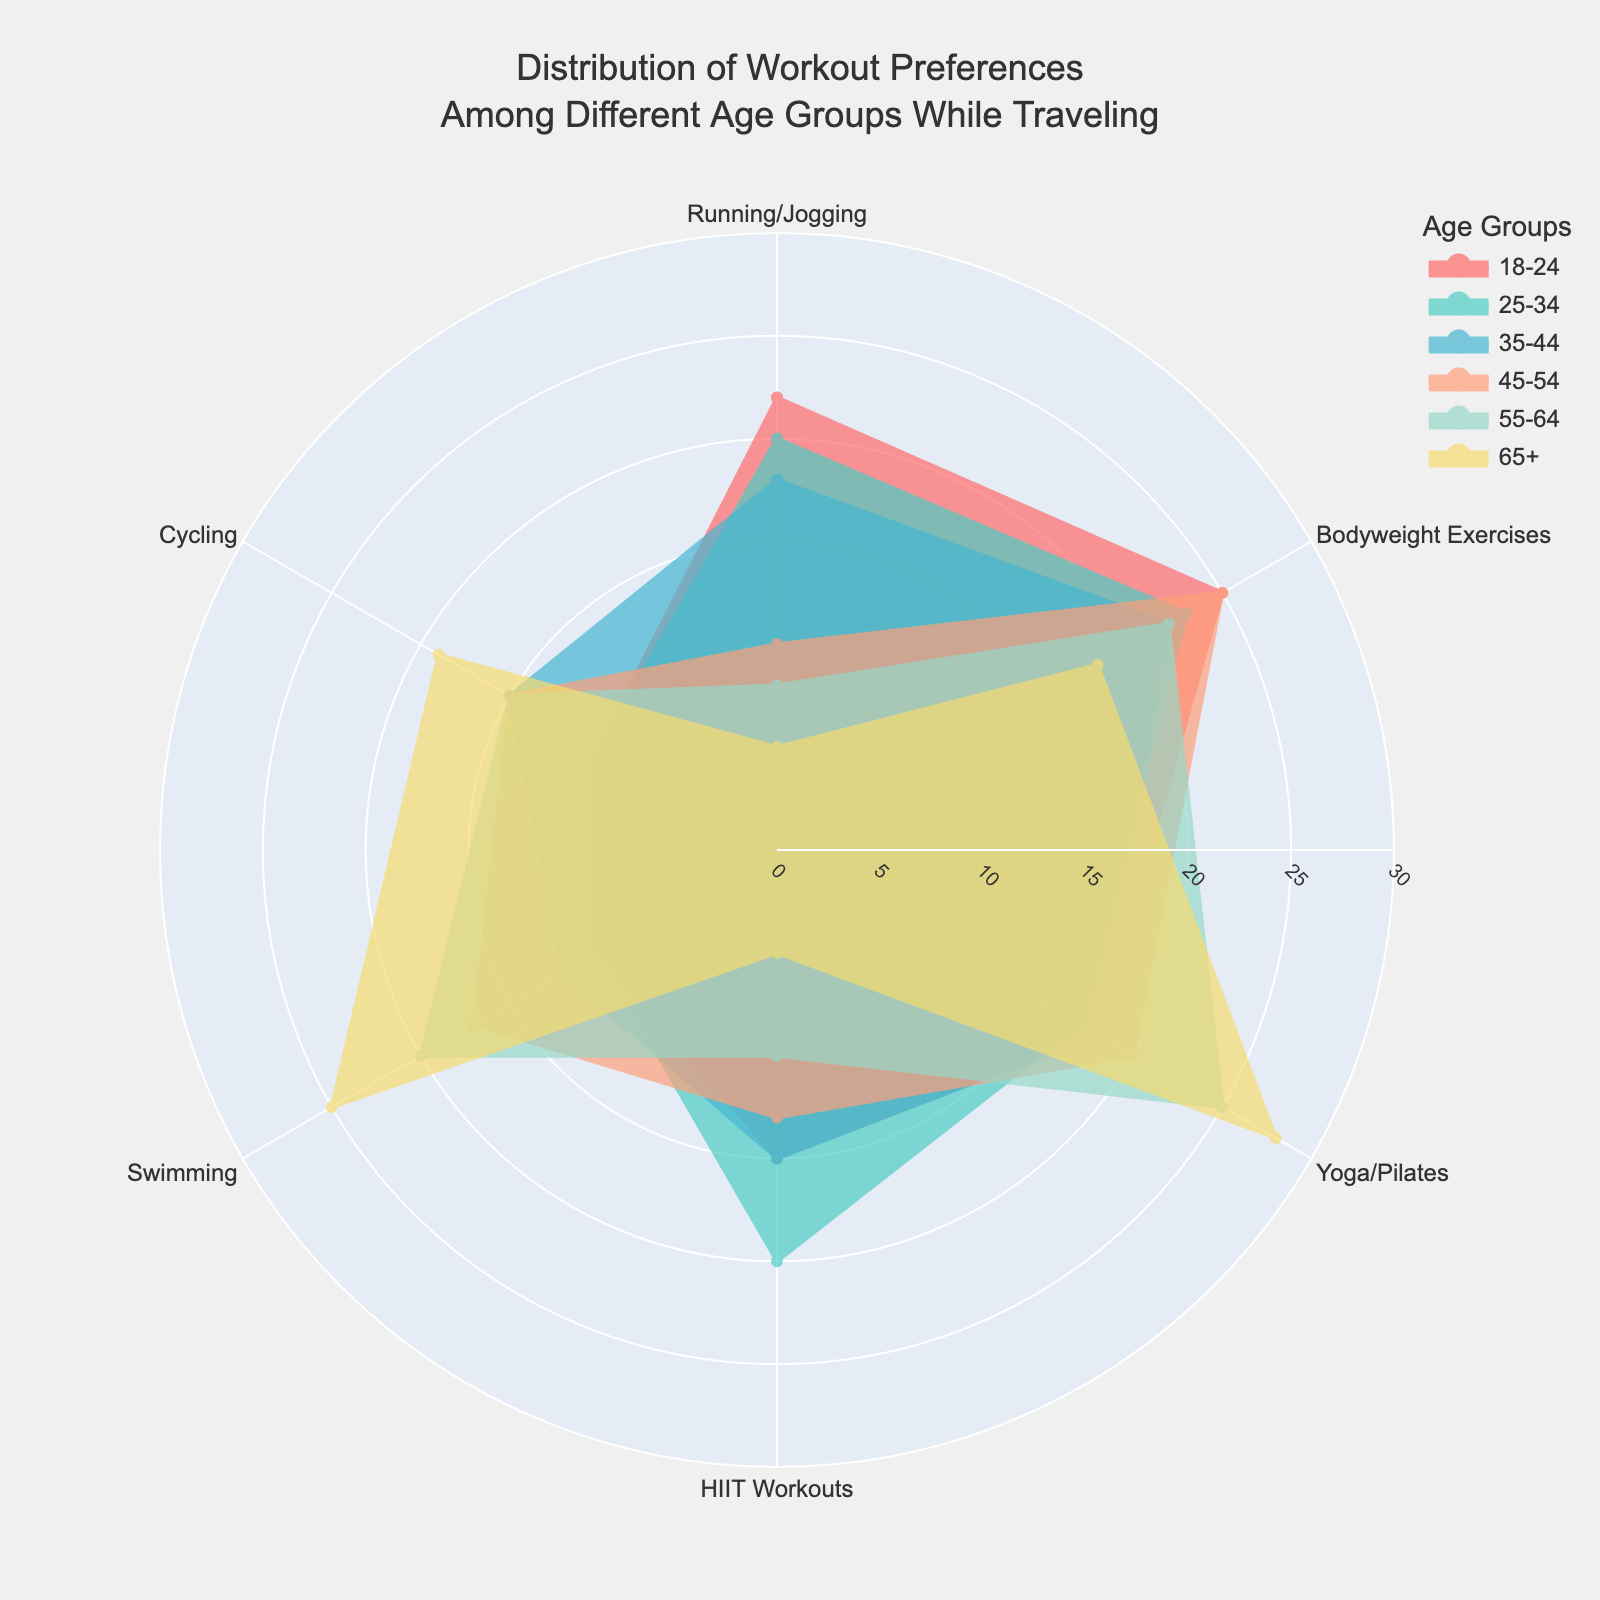What are the top two preferred activities for the 18-24 age group? According to the polar area chart, by looking at the 18-24 age group section, the largest two areas are for Bodyweight Exercises and Running/Jogging.
Answer: Bodyweight Exercises and Running/Jogging Which activity has consistent preference across all age groups? By looking at all sections of the chart, Bodyweight Exercises appear prominently across all age groups with varying percentages.
Answer: Bodyweight Exercises Compare the preference for Yoga/Pilates between the 55-64 and 65+ age groups. By examining the values for Yoga/Pilates in both sections, it's noticeable that the 65+ age group has a higher preference (28%) compared to the 55-64 age group (25%).
Answer: 65+ has higher preference Which age group has the highest preference for HIIT Workouts? By comparing the segments for HIIT Workouts across all age groups, the 25-34 group shows the highest percentage (20%).
Answer: 25-34 age group What is the range of percentages for Swimming across all age groups? By locating the values for Swimming in each age group segment, the percentages range from 10% (18-24 and 25-34) to 25% (65+).
Answer: 10% to 25% What is the least popular activity for the 65+ age group? The smallest segment in the 65+ age group section indicates that HIIT Workouts is the least preferred at 5%.
Answer: HIIT Workouts How does the preference for Running/Jogging compare between the 18-24 and 45-54 age groups? Comparing the segments, the 18-24 age group has a higher preference (22%) whereas the 45-54 age group has a lower preference (10%).
Answer: 18-24 has higher preference What is the combined percentage of preference for Cycling in the 35-44 and 55-64 age groups? The values for Cycling are 15% for 35-44 and 15% for 55-64. Adding them gives 15% + 15% = 30%.
Answer: 30% 